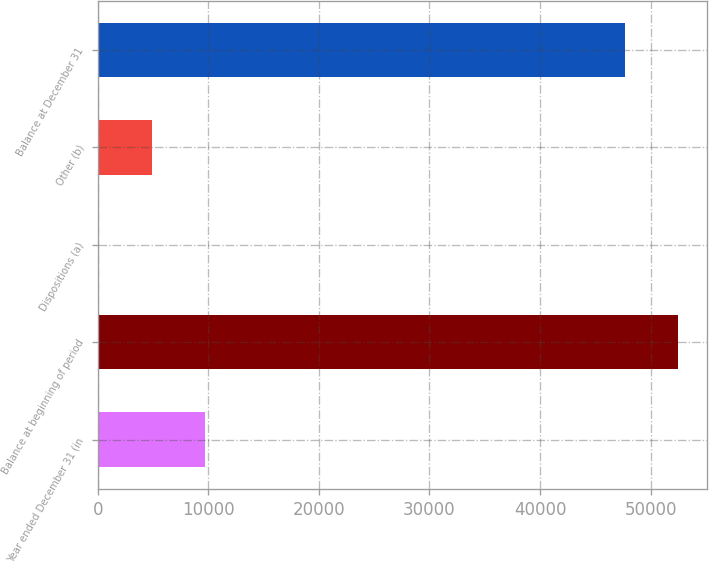<chart> <loc_0><loc_0><loc_500><loc_500><bar_chart><fcel>Year ended December 31 (in<fcel>Balance at beginning of period<fcel>Dispositions (a)<fcel>Other (b)<fcel>Balance at December 31<nl><fcel>9680.2<fcel>52447.1<fcel>80<fcel>4880.1<fcel>47647<nl></chart> 